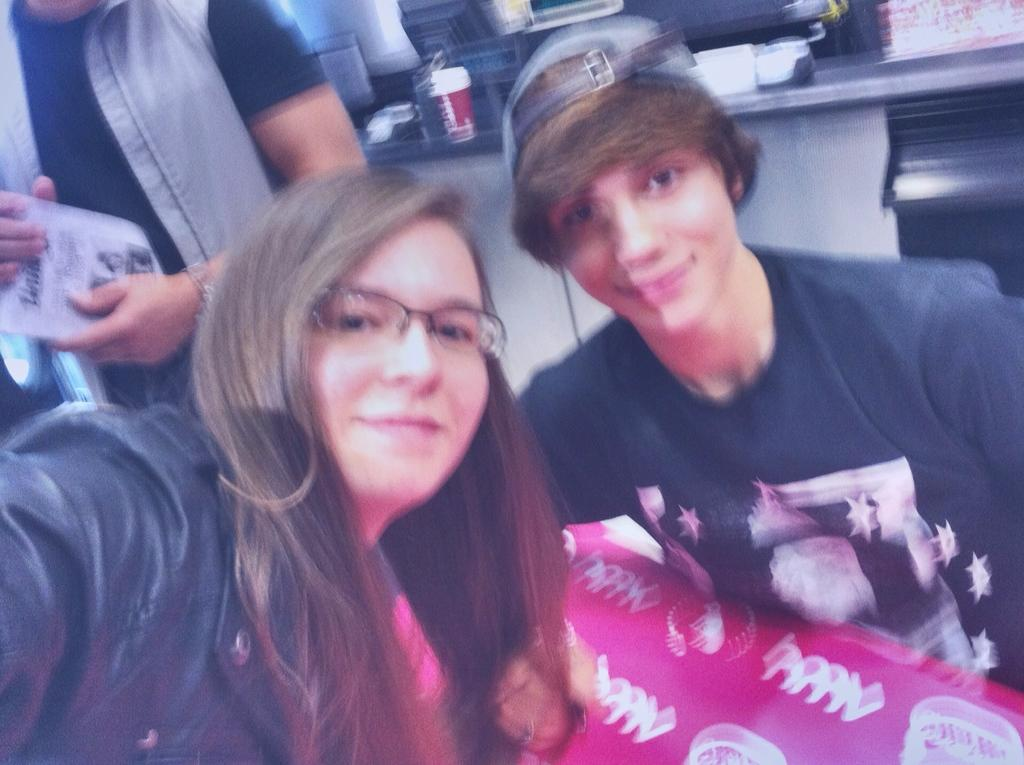How many people are smiling in the image? There are two persons smiling in the image. Can you describe the person in the background? There is another person standing in the background of the image. What can be seen on the cabinet in the image? There are items on a cabinet in the image. What type of verse is written on the jeans in the image? There are no jeans or verses present in the image. What month is highlighted on the calendar in the image? There is no calendar present in the image. 